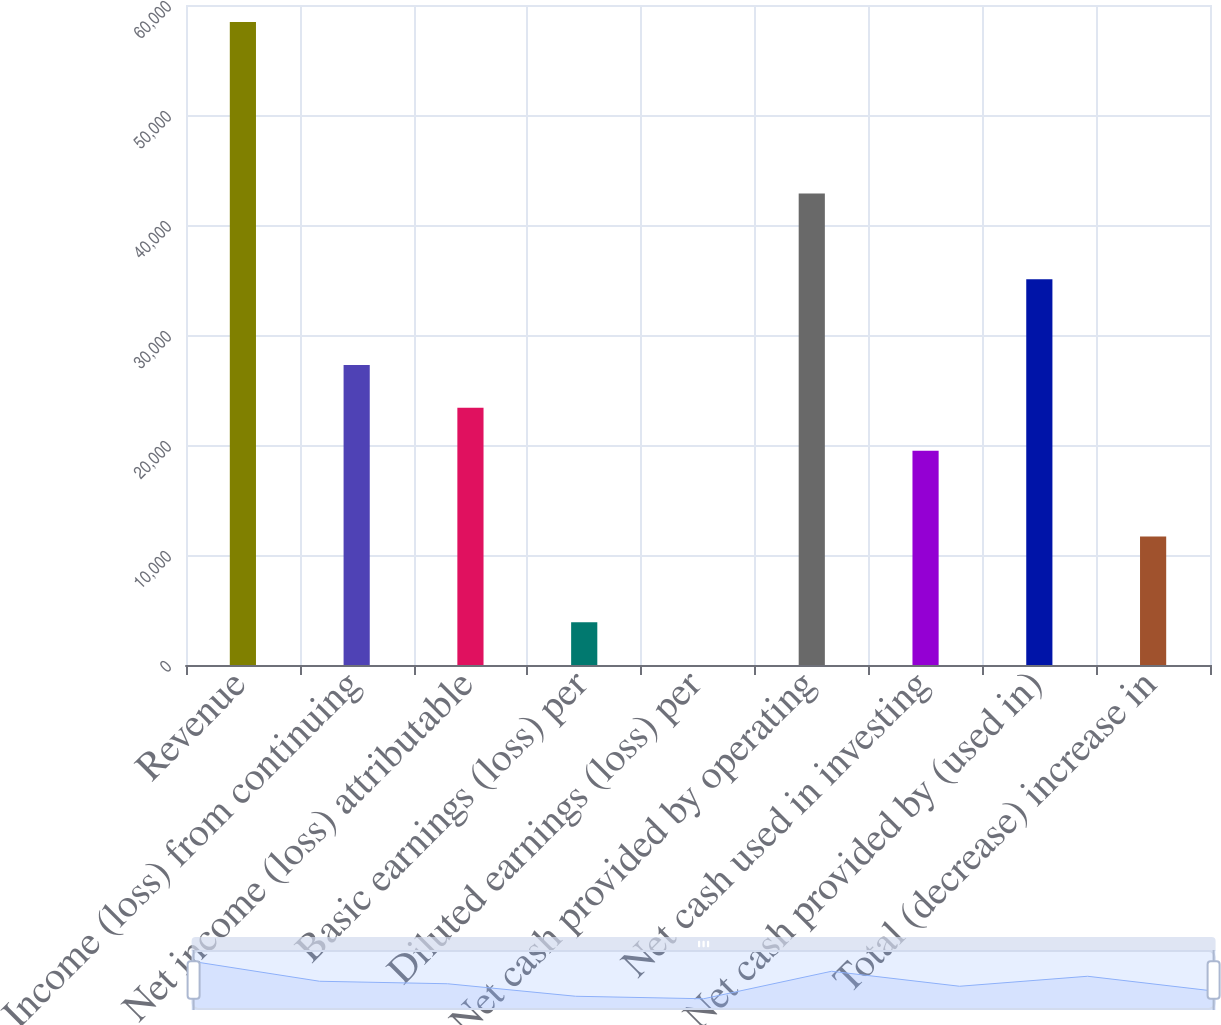Convert chart. <chart><loc_0><loc_0><loc_500><loc_500><bar_chart><fcel>Revenue<fcel>Income (loss) from continuing<fcel>Net income (loss) attributable<fcel>Basic earnings (loss) per<fcel>Diluted earnings (loss) per<fcel>Net cash provided by operating<fcel>Net cash used in investing<fcel>Net cash provided by (used in)<fcel>Total (decrease) increase in<nl><fcel>58448.4<fcel>27276.5<fcel>23380<fcel>3897.55<fcel>1.06<fcel>42862.4<fcel>19483.5<fcel>35069.5<fcel>11690.5<nl></chart> 